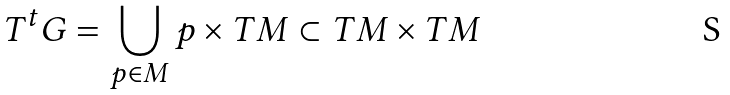<formula> <loc_0><loc_0><loc_500><loc_500>T ^ { t } G = \bigcup _ { p \in M } p \times T M \subset T M \times T M</formula> 